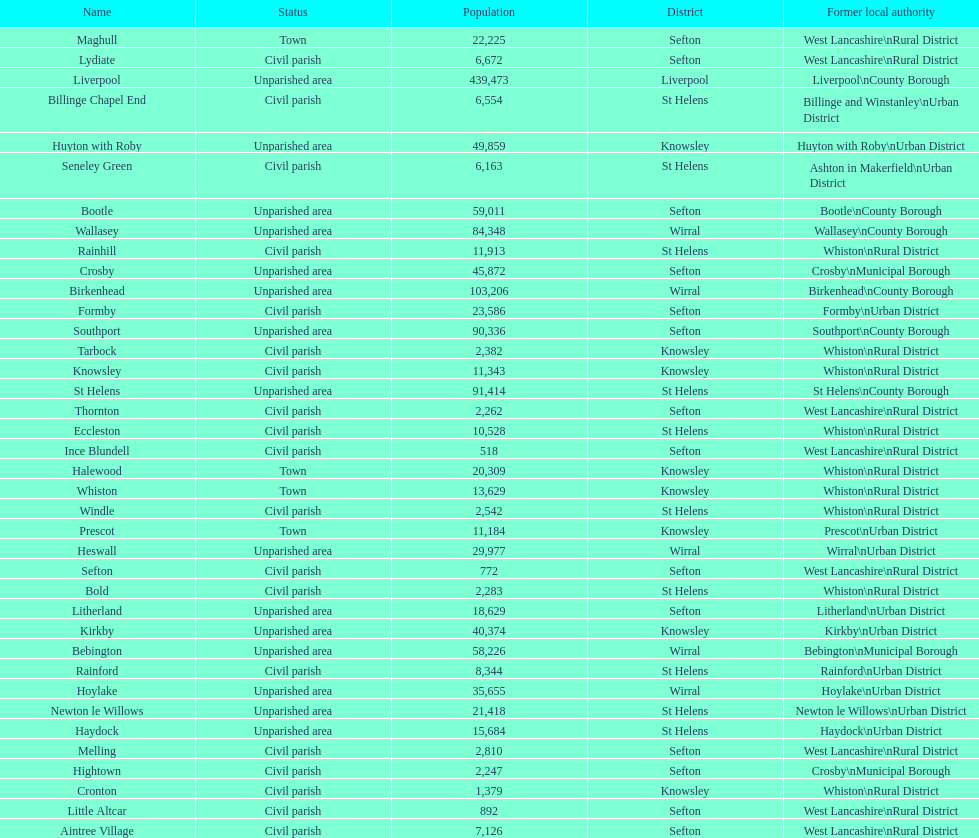What is the largest area in terms of population? Liverpool. 